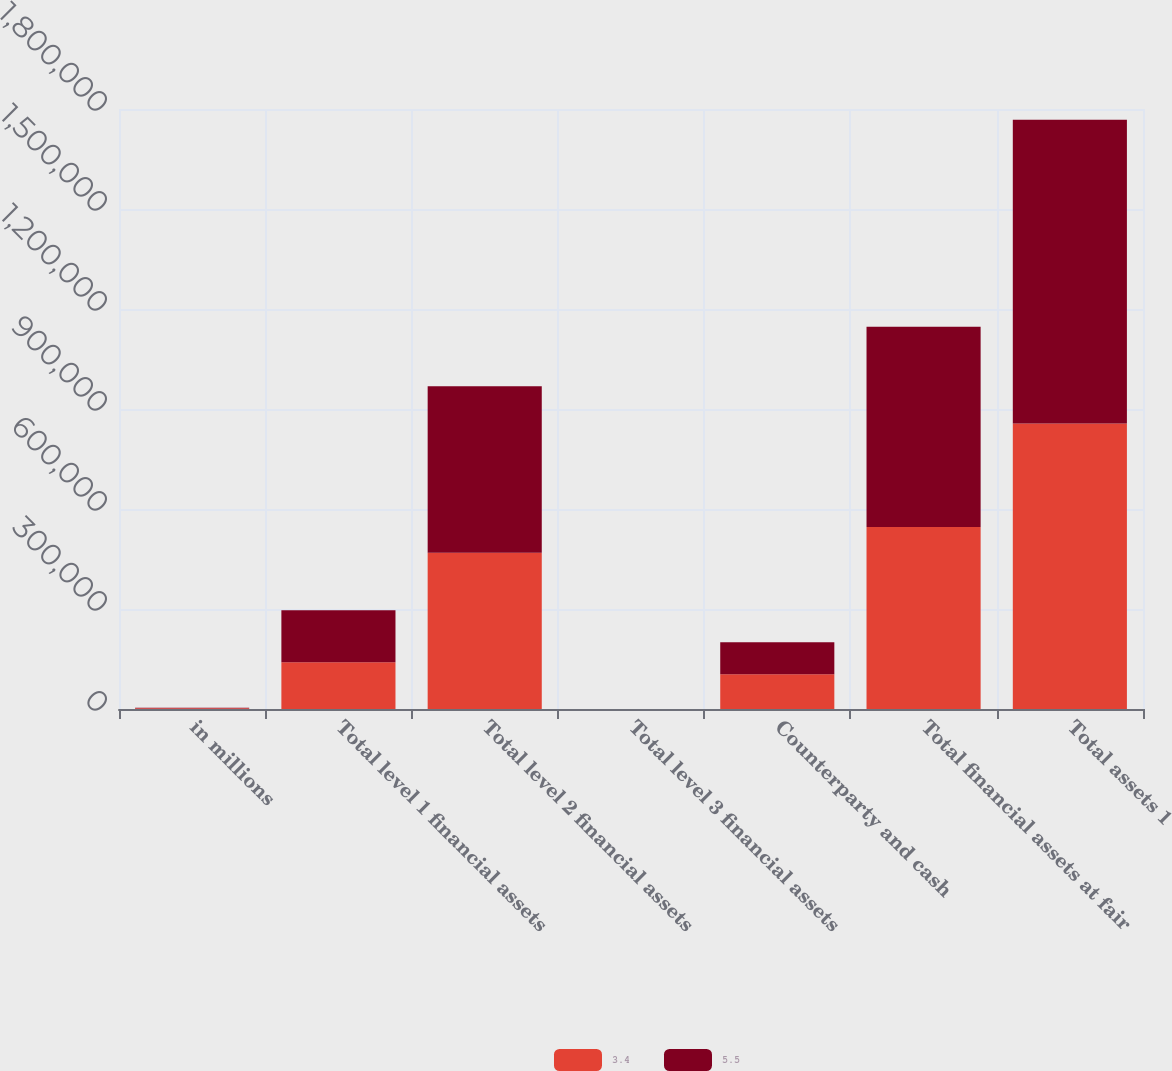Convert chart to OTSL. <chart><loc_0><loc_0><loc_500><loc_500><stacked_bar_chart><ecel><fcel>in millions<fcel>Total level 1 financial assets<fcel>Total level 2 financial assets<fcel>Total level 3 financial assets<fcel>Counterparty and cash<fcel>Total financial assets at fair<fcel>Total assets 1<nl><fcel>3.4<fcel>2014<fcel>140221<fcel>468678<fcel>4.9<fcel>104616<fcel>546288<fcel>856240<nl><fcel>5.5<fcel>2013<fcel>156030<fcel>499480<fcel>4.4<fcel>95350<fcel>600173<fcel>911507<nl></chart> 